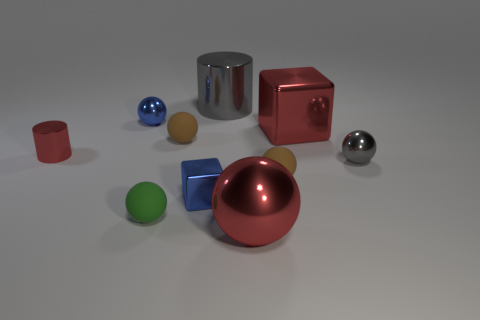Subtract all big red metallic spheres. How many spheres are left? 5 Subtract all brown balls. How many balls are left? 4 Subtract all yellow spheres. Subtract all green blocks. How many spheres are left? 6 Subtract all spheres. How many objects are left? 4 Add 2 green matte things. How many green matte things are left? 3 Add 1 small brown spheres. How many small brown spheres exist? 3 Subtract 0 brown cylinders. How many objects are left? 10 Subtract all small green things. Subtract all red objects. How many objects are left? 6 